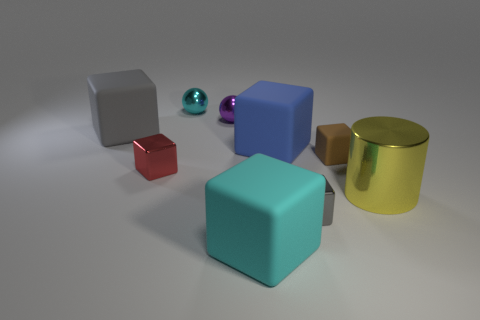Is there anything else that is the same shape as the big yellow shiny object?
Your answer should be compact. No. Is the number of metal things that are in front of the yellow object greater than the number of big metal cylinders on the left side of the large blue thing?
Provide a short and direct response. Yes. There is a cyan thing that is behind the cyan matte thing in front of the gray thing behind the large shiny object; how big is it?
Make the answer very short. Small. Is the material of the cylinder the same as the small object that is in front of the red metal thing?
Provide a succinct answer. Yes. Does the large cyan thing have the same shape as the tiny cyan object?
Your answer should be compact. No. What number of other things are made of the same material as the big gray block?
Offer a very short reply. 3. How many small metallic things are the same shape as the large blue rubber thing?
Ensure brevity in your answer.  2. The cube that is right of the blue block and in front of the large cylinder is what color?
Offer a very short reply. Gray. How many large blue matte things are there?
Provide a succinct answer. 1. Is the size of the yellow metal cylinder the same as the gray matte cube?
Your response must be concise. Yes. 